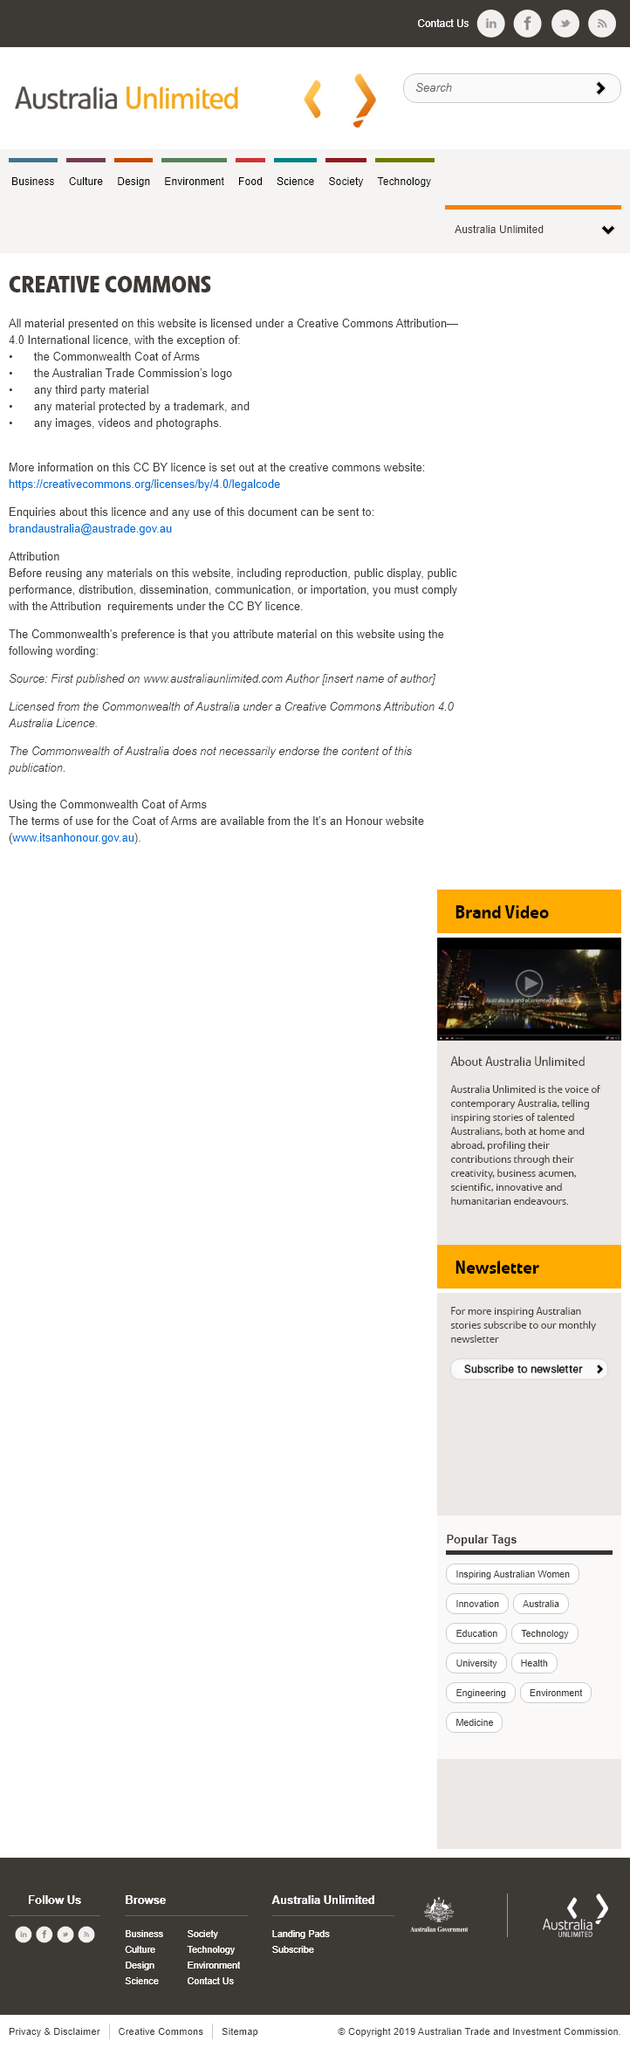List a handful of essential elements in this visual. The Commonwealth Coat of Arms is not licensed under a Creative Commons Attribution license. The Australian Trade Commission's logo is not licensed under a Creative Commons Attribution license. Yes, there are exceptions to the rule that all material is licensed under a Creative Commons Attribution license. 